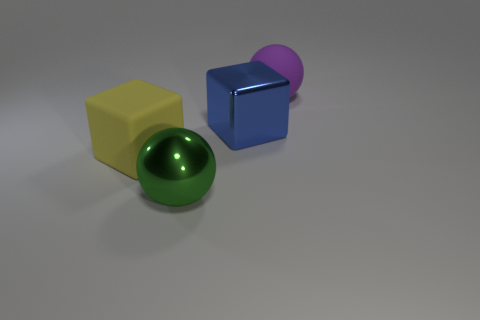There is a metallic object in front of the large block on the right side of the block to the left of the metal cube; what is its size?
Offer a terse response. Large. What size is the green sphere that is the same material as the blue block?
Give a very brief answer. Large. Is the size of the blue metal cube the same as the rubber cube that is in front of the big metal block?
Offer a very short reply. Yes. The big object that is behind the big blue object has what shape?
Keep it short and to the point. Sphere. Is there a big metallic ball that is behind the matte object that is left of the large object in front of the large yellow object?
Give a very brief answer. No. What material is the other object that is the same shape as the large green metal object?
Provide a short and direct response. Rubber. Is there anything else that is made of the same material as the big purple sphere?
Offer a very short reply. Yes. How many cylinders are either matte objects or large yellow objects?
Offer a very short reply. 0. Do the metallic object in front of the big yellow object and the block that is right of the large green ball have the same size?
Make the answer very short. Yes. What material is the big cube on the right side of the big matte object in front of the big purple matte thing made of?
Your answer should be very brief. Metal. 